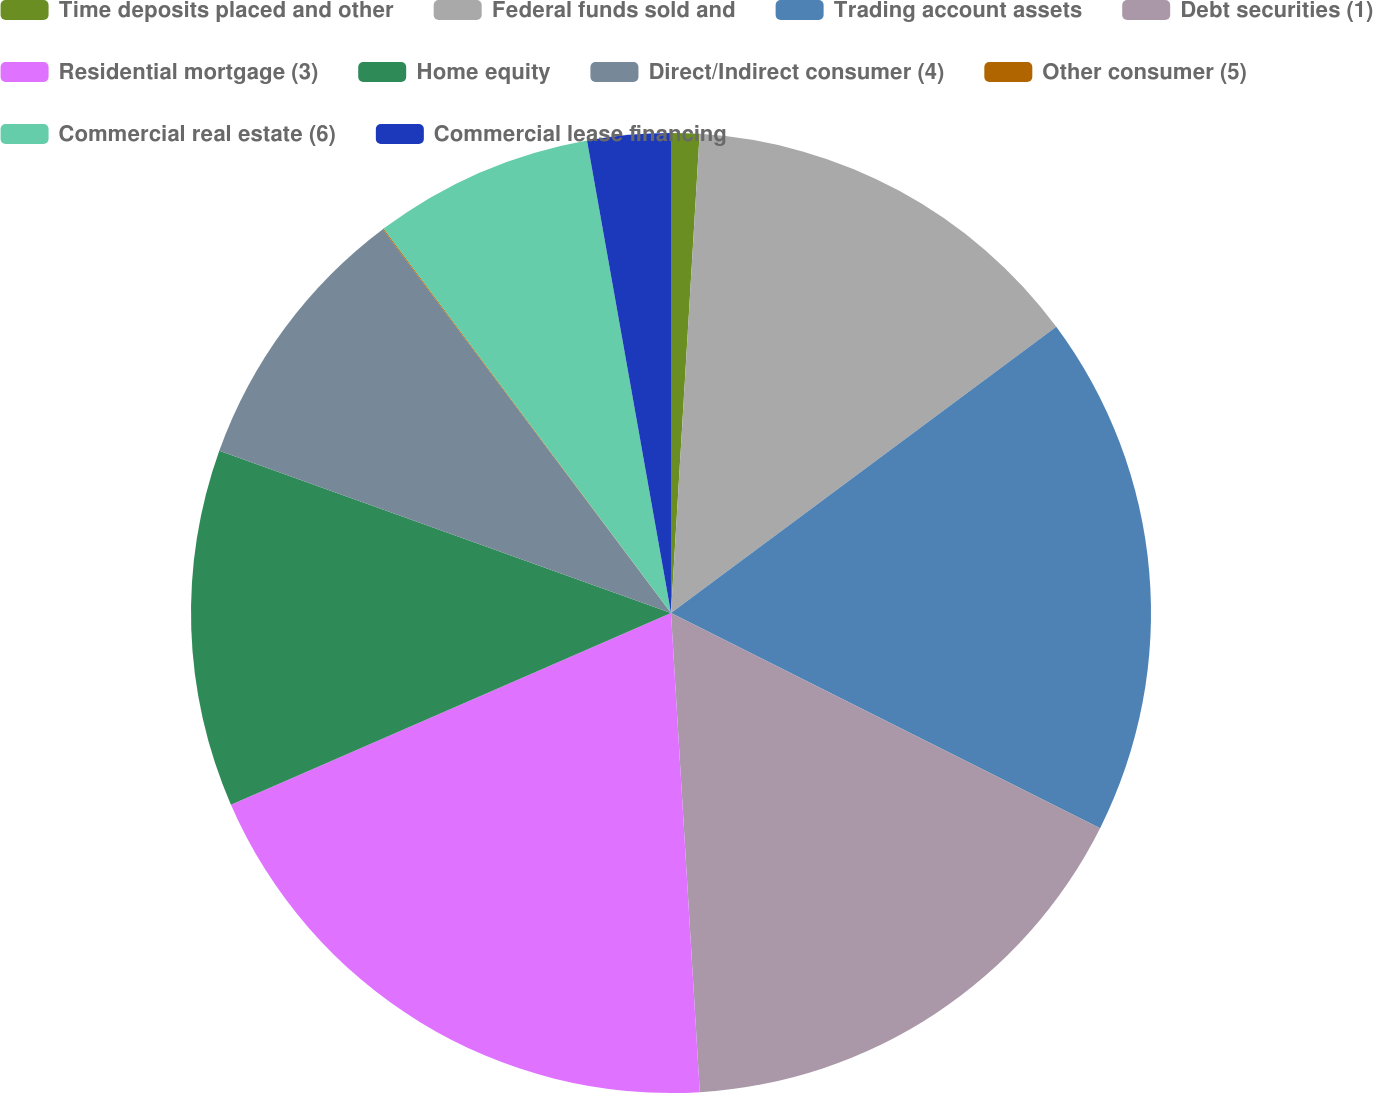Convert chart. <chart><loc_0><loc_0><loc_500><loc_500><pie_chart><fcel>Time deposits placed and other<fcel>Federal funds sold and<fcel>Trading account assets<fcel>Debt securities (1)<fcel>Residential mortgage (3)<fcel>Home equity<fcel>Direct/Indirect consumer (4)<fcel>Other consumer (5)<fcel>Commercial real estate (6)<fcel>Commercial lease financing<nl><fcel>0.95%<fcel>13.88%<fcel>17.57%<fcel>16.65%<fcel>19.42%<fcel>12.03%<fcel>9.26%<fcel>0.03%<fcel>7.42%<fcel>2.8%<nl></chart> 